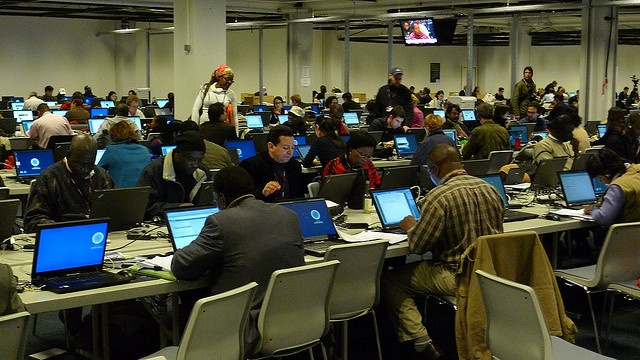Describe the objects in this image and their specific colors. I can see people in black, tan, olive, and gray tones, laptop in black, darkgreen, gray, and olive tones, people in black and olive tones, people in black, darkgreen, and gray tones, and chair in black, darkgreen, olive, and khaki tones in this image. 